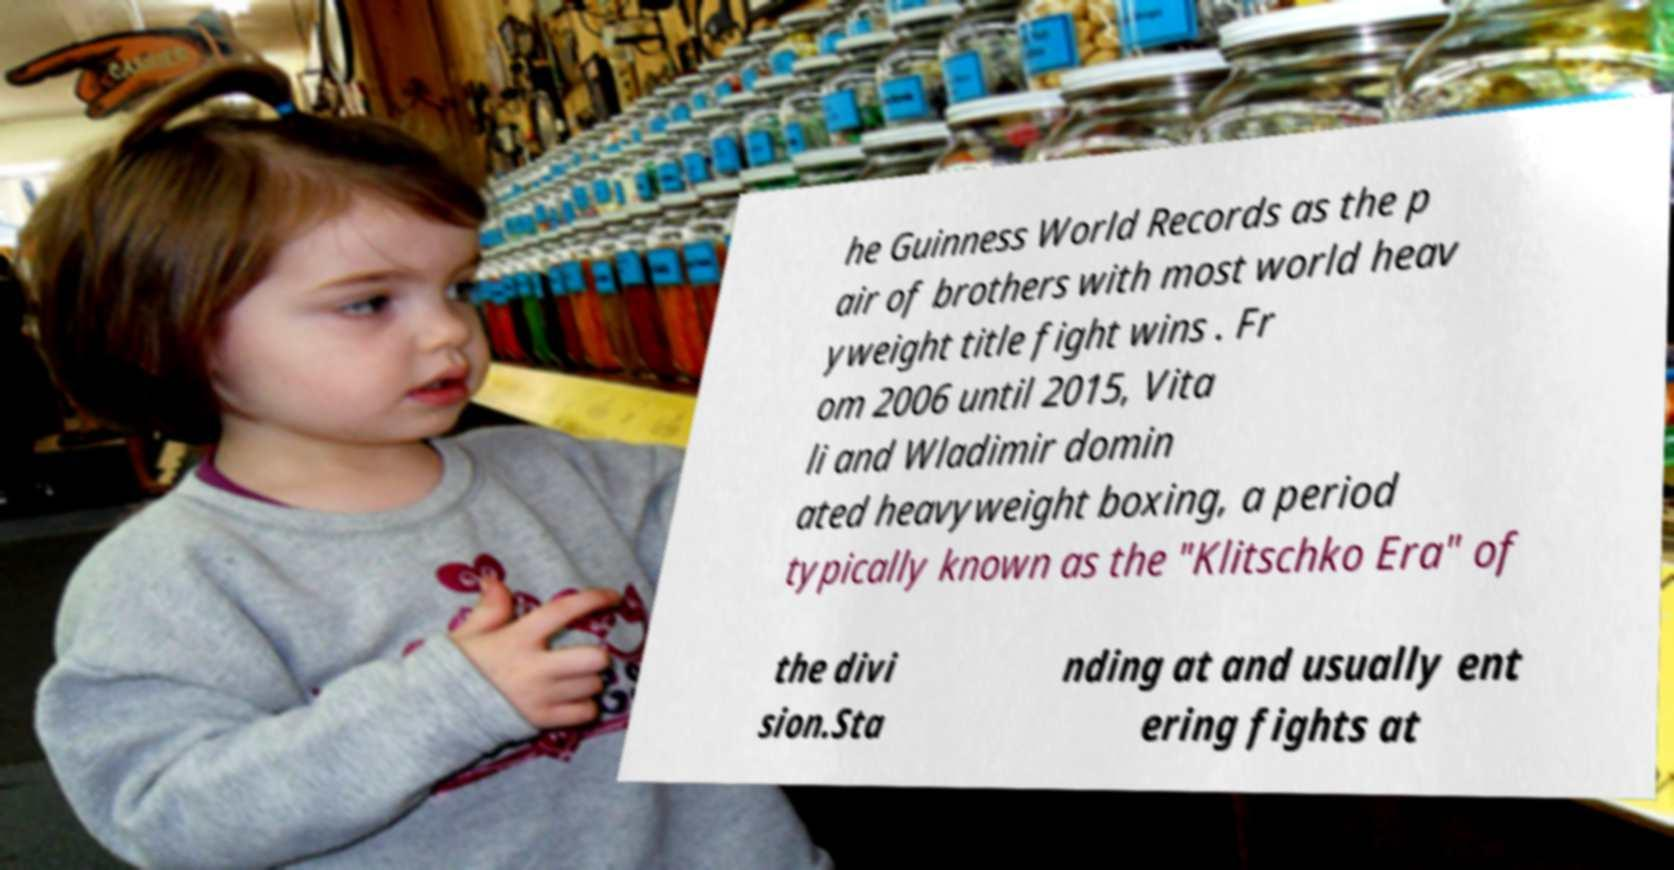Please identify and transcribe the text found in this image. he Guinness World Records as the p air of brothers with most world heav yweight title fight wins . Fr om 2006 until 2015, Vita li and Wladimir domin ated heavyweight boxing, a period typically known as the "Klitschko Era" of the divi sion.Sta nding at and usually ent ering fights at 